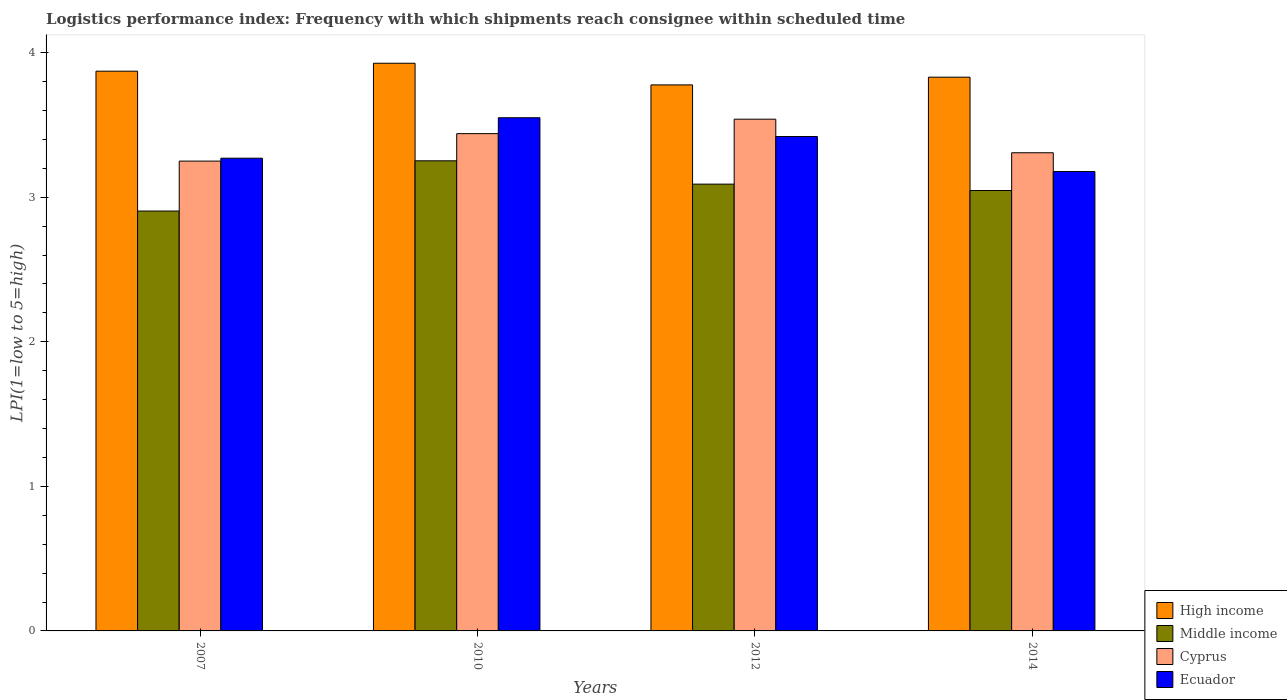Are the number of bars per tick equal to the number of legend labels?
Your response must be concise. Yes. How many bars are there on the 3rd tick from the left?
Your response must be concise. 4. What is the label of the 3rd group of bars from the left?
Provide a short and direct response. 2012. What is the logistics performance index in High income in 2007?
Provide a succinct answer. 3.87. Across all years, what is the maximum logistics performance index in Ecuador?
Keep it short and to the point. 3.55. Across all years, what is the minimum logistics performance index in Middle income?
Provide a succinct answer. 2.9. In which year was the logistics performance index in High income maximum?
Your answer should be very brief. 2010. In which year was the logistics performance index in Cyprus minimum?
Give a very brief answer. 2007. What is the total logistics performance index in High income in the graph?
Provide a succinct answer. 15.41. What is the difference between the logistics performance index in High income in 2007 and that in 2014?
Keep it short and to the point. 0.04. What is the difference between the logistics performance index in Cyprus in 2010 and the logistics performance index in Ecuador in 2014?
Your response must be concise. 0.26. What is the average logistics performance index in High income per year?
Make the answer very short. 3.85. In the year 2012, what is the difference between the logistics performance index in High income and logistics performance index in Middle income?
Keep it short and to the point. 0.69. In how many years, is the logistics performance index in Cyprus greater than 0.4?
Keep it short and to the point. 4. What is the ratio of the logistics performance index in Cyprus in 2007 to that in 2014?
Your answer should be very brief. 0.98. Is the difference between the logistics performance index in High income in 2007 and 2010 greater than the difference between the logistics performance index in Middle income in 2007 and 2010?
Provide a short and direct response. Yes. What is the difference between the highest and the second highest logistics performance index in High income?
Provide a short and direct response. 0.05. What is the difference between the highest and the lowest logistics performance index in Cyprus?
Your answer should be compact. 0.29. In how many years, is the logistics performance index in Middle income greater than the average logistics performance index in Middle income taken over all years?
Provide a short and direct response. 2. Is the sum of the logistics performance index in Ecuador in 2007 and 2014 greater than the maximum logistics performance index in High income across all years?
Give a very brief answer. Yes. What is the difference between two consecutive major ticks on the Y-axis?
Your answer should be compact. 1. Are the values on the major ticks of Y-axis written in scientific E-notation?
Give a very brief answer. No. Does the graph contain any zero values?
Make the answer very short. No. Where does the legend appear in the graph?
Give a very brief answer. Bottom right. What is the title of the graph?
Offer a very short reply. Logistics performance index: Frequency with which shipments reach consignee within scheduled time. Does "Liberia" appear as one of the legend labels in the graph?
Offer a terse response. No. What is the label or title of the X-axis?
Offer a very short reply. Years. What is the label or title of the Y-axis?
Make the answer very short. LPI(1=low to 5=high). What is the LPI(1=low to 5=high) in High income in 2007?
Make the answer very short. 3.87. What is the LPI(1=low to 5=high) of Middle income in 2007?
Your answer should be very brief. 2.9. What is the LPI(1=low to 5=high) in Ecuador in 2007?
Provide a succinct answer. 3.27. What is the LPI(1=low to 5=high) of High income in 2010?
Provide a succinct answer. 3.93. What is the LPI(1=low to 5=high) in Middle income in 2010?
Make the answer very short. 3.25. What is the LPI(1=low to 5=high) in Cyprus in 2010?
Provide a short and direct response. 3.44. What is the LPI(1=low to 5=high) of Ecuador in 2010?
Make the answer very short. 3.55. What is the LPI(1=low to 5=high) in High income in 2012?
Give a very brief answer. 3.78. What is the LPI(1=low to 5=high) in Middle income in 2012?
Your response must be concise. 3.09. What is the LPI(1=low to 5=high) of Cyprus in 2012?
Your answer should be very brief. 3.54. What is the LPI(1=low to 5=high) in Ecuador in 2012?
Your answer should be compact. 3.42. What is the LPI(1=low to 5=high) of High income in 2014?
Provide a short and direct response. 3.83. What is the LPI(1=low to 5=high) in Middle income in 2014?
Give a very brief answer. 3.05. What is the LPI(1=low to 5=high) of Cyprus in 2014?
Offer a very short reply. 3.31. What is the LPI(1=low to 5=high) of Ecuador in 2014?
Your response must be concise. 3.18. Across all years, what is the maximum LPI(1=low to 5=high) in High income?
Provide a short and direct response. 3.93. Across all years, what is the maximum LPI(1=low to 5=high) in Middle income?
Make the answer very short. 3.25. Across all years, what is the maximum LPI(1=low to 5=high) of Cyprus?
Keep it short and to the point. 3.54. Across all years, what is the maximum LPI(1=low to 5=high) of Ecuador?
Give a very brief answer. 3.55. Across all years, what is the minimum LPI(1=low to 5=high) in High income?
Ensure brevity in your answer.  3.78. Across all years, what is the minimum LPI(1=low to 5=high) in Middle income?
Ensure brevity in your answer.  2.9. Across all years, what is the minimum LPI(1=low to 5=high) in Ecuador?
Keep it short and to the point. 3.18. What is the total LPI(1=low to 5=high) in High income in the graph?
Provide a succinct answer. 15.41. What is the total LPI(1=low to 5=high) of Middle income in the graph?
Your response must be concise. 12.29. What is the total LPI(1=low to 5=high) in Cyprus in the graph?
Ensure brevity in your answer.  13.54. What is the total LPI(1=low to 5=high) of Ecuador in the graph?
Give a very brief answer. 13.42. What is the difference between the LPI(1=low to 5=high) in High income in 2007 and that in 2010?
Provide a succinct answer. -0.05. What is the difference between the LPI(1=low to 5=high) of Middle income in 2007 and that in 2010?
Offer a very short reply. -0.35. What is the difference between the LPI(1=low to 5=high) of Cyprus in 2007 and that in 2010?
Provide a short and direct response. -0.19. What is the difference between the LPI(1=low to 5=high) in Ecuador in 2007 and that in 2010?
Make the answer very short. -0.28. What is the difference between the LPI(1=low to 5=high) of High income in 2007 and that in 2012?
Make the answer very short. 0.09. What is the difference between the LPI(1=low to 5=high) of Middle income in 2007 and that in 2012?
Ensure brevity in your answer.  -0.19. What is the difference between the LPI(1=low to 5=high) of Cyprus in 2007 and that in 2012?
Give a very brief answer. -0.29. What is the difference between the LPI(1=low to 5=high) in Ecuador in 2007 and that in 2012?
Provide a succinct answer. -0.15. What is the difference between the LPI(1=low to 5=high) in High income in 2007 and that in 2014?
Offer a very short reply. 0.04. What is the difference between the LPI(1=low to 5=high) in Middle income in 2007 and that in 2014?
Ensure brevity in your answer.  -0.14. What is the difference between the LPI(1=low to 5=high) of Cyprus in 2007 and that in 2014?
Offer a very short reply. -0.06. What is the difference between the LPI(1=low to 5=high) in Ecuador in 2007 and that in 2014?
Make the answer very short. 0.09. What is the difference between the LPI(1=low to 5=high) in High income in 2010 and that in 2012?
Offer a terse response. 0.15. What is the difference between the LPI(1=low to 5=high) of Middle income in 2010 and that in 2012?
Your answer should be compact. 0.16. What is the difference between the LPI(1=low to 5=high) of Cyprus in 2010 and that in 2012?
Provide a succinct answer. -0.1. What is the difference between the LPI(1=low to 5=high) in Ecuador in 2010 and that in 2012?
Give a very brief answer. 0.13. What is the difference between the LPI(1=low to 5=high) in High income in 2010 and that in 2014?
Your answer should be very brief. 0.1. What is the difference between the LPI(1=low to 5=high) of Middle income in 2010 and that in 2014?
Give a very brief answer. 0.21. What is the difference between the LPI(1=low to 5=high) in Cyprus in 2010 and that in 2014?
Offer a very short reply. 0.13. What is the difference between the LPI(1=low to 5=high) in Ecuador in 2010 and that in 2014?
Keep it short and to the point. 0.37. What is the difference between the LPI(1=low to 5=high) in High income in 2012 and that in 2014?
Keep it short and to the point. -0.05. What is the difference between the LPI(1=low to 5=high) in Middle income in 2012 and that in 2014?
Your response must be concise. 0.04. What is the difference between the LPI(1=low to 5=high) in Cyprus in 2012 and that in 2014?
Offer a very short reply. 0.23. What is the difference between the LPI(1=low to 5=high) of Ecuador in 2012 and that in 2014?
Your response must be concise. 0.24. What is the difference between the LPI(1=low to 5=high) of High income in 2007 and the LPI(1=low to 5=high) of Middle income in 2010?
Your response must be concise. 0.62. What is the difference between the LPI(1=low to 5=high) of High income in 2007 and the LPI(1=low to 5=high) of Cyprus in 2010?
Your answer should be compact. 0.43. What is the difference between the LPI(1=low to 5=high) in High income in 2007 and the LPI(1=low to 5=high) in Ecuador in 2010?
Your answer should be very brief. 0.32. What is the difference between the LPI(1=low to 5=high) in Middle income in 2007 and the LPI(1=low to 5=high) in Cyprus in 2010?
Your response must be concise. -0.54. What is the difference between the LPI(1=low to 5=high) in Middle income in 2007 and the LPI(1=low to 5=high) in Ecuador in 2010?
Your answer should be compact. -0.65. What is the difference between the LPI(1=low to 5=high) of Cyprus in 2007 and the LPI(1=low to 5=high) of Ecuador in 2010?
Keep it short and to the point. -0.3. What is the difference between the LPI(1=low to 5=high) of High income in 2007 and the LPI(1=low to 5=high) of Middle income in 2012?
Your response must be concise. 0.78. What is the difference between the LPI(1=low to 5=high) in High income in 2007 and the LPI(1=low to 5=high) in Cyprus in 2012?
Your response must be concise. 0.33. What is the difference between the LPI(1=low to 5=high) in High income in 2007 and the LPI(1=low to 5=high) in Ecuador in 2012?
Give a very brief answer. 0.45. What is the difference between the LPI(1=low to 5=high) of Middle income in 2007 and the LPI(1=low to 5=high) of Cyprus in 2012?
Offer a terse response. -0.64. What is the difference between the LPI(1=low to 5=high) in Middle income in 2007 and the LPI(1=low to 5=high) in Ecuador in 2012?
Your answer should be very brief. -0.52. What is the difference between the LPI(1=low to 5=high) in Cyprus in 2007 and the LPI(1=low to 5=high) in Ecuador in 2012?
Ensure brevity in your answer.  -0.17. What is the difference between the LPI(1=low to 5=high) in High income in 2007 and the LPI(1=low to 5=high) in Middle income in 2014?
Ensure brevity in your answer.  0.83. What is the difference between the LPI(1=low to 5=high) in High income in 2007 and the LPI(1=low to 5=high) in Cyprus in 2014?
Give a very brief answer. 0.56. What is the difference between the LPI(1=low to 5=high) in High income in 2007 and the LPI(1=low to 5=high) in Ecuador in 2014?
Your answer should be compact. 0.69. What is the difference between the LPI(1=low to 5=high) in Middle income in 2007 and the LPI(1=low to 5=high) in Cyprus in 2014?
Provide a succinct answer. -0.4. What is the difference between the LPI(1=low to 5=high) of Middle income in 2007 and the LPI(1=low to 5=high) of Ecuador in 2014?
Your answer should be very brief. -0.27. What is the difference between the LPI(1=low to 5=high) of Cyprus in 2007 and the LPI(1=low to 5=high) of Ecuador in 2014?
Keep it short and to the point. 0.07. What is the difference between the LPI(1=low to 5=high) of High income in 2010 and the LPI(1=low to 5=high) of Middle income in 2012?
Ensure brevity in your answer.  0.84. What is the difference between the LPI(1=low to 5=high) in High income in 2010 and the LPI(1=low to 5=high) in Cyprus in 2012?
Give a very brief answer. 0.39. What is the difference between the LPI(1=low to 5=high) of High income in 2010 and the LPI(1=low to 5=high) of Ecuador in 2012?
Your response must be concise. 0.51. What is the difference between the LPI(1=low to 5=high) in Middle income in 2010 and the LPI(1=low to 5=high) in Cyprus in 2012?
Make the answer very short. -0.29. What is the difference between the LPI(1=low to 5=high) in Middle income in 2010 and the LPI(1=low to 5=high) in Ecuador in 2012?
Give a very brief answer. -0.17. What is the difference between the LPI(1=low to 5=high) of Cyprus in 2010 and the LPI(1=low to 5=high) of Ecuador in 2012?
Give a very brief answer. 0.02. What is the difference between the LPI(1=low to 5=high) in High income in 2010 and the LPI(1=low to 5=high) in Middle income in 2014?
Offer a terse response. 0.88. What is the difference between the LPI(1=low to 5=high) of High income in 2010 and the LPI(1=low to 5=high) of Cyprus in 2014?
Your answer should be compact. 0.62. What is the difference between the LPI(1=low to 5=high) in High income in 2010 and the LPI(1=low to 5=high) in Ecuador in 2014?
Provide a succinct answer. 0.75. What is the difference between the LPI(1=low to 5=high) in Middle income in 2010 and the LPI(1=low to 5=high) in Cyprus in 2014?
Make the answer very short. -0.06. What is the difference between the LPI(1=low to 5=high) of Middle income in 2010 and the LPI(1=low to 5=high) of Ecuador in 2014?
Ensure brevity in your answer.  0.07. What is the difference between the LPI(1=low to 5=high) in Cyprus in 2010 and the LPI(1=low to 5=high) in Ecuador in 2014?
Provide a short and direct response. 0.26. What is the difference between the LPI(1=low to 5=high) of High income in 2012 and the LPI(1=low to 5=high) of Middle income in 2014?
Keep it short and to the point. 0.73. What is the difference between the LPI(1=low to 5=high) in High income in 2012 and the LPI(1=low to 5=high) in Cyprus in 2014?
Keep it short and to the point. 0.47. What is the difference between the LPI(1=low to 5=high) in High income in 2012 and the LPI(1=low to 5=high) in Ecuador in 2014?
Provide a succinct answer. 0.6. What is the difference between the LPI(1=low to 5=high) of Middle income in 2012 and the LPI(1=low to 5=high) of Cyprus in 2014?
Make the answer very short. -0.22. What is the difference between the LPI(1=low to 5=high) in Middle income in 2012 and the LPI(1=low to 5=high) in Ecuador in 2014?
Your answer should be very brief. -0.09. What is the difference between the LPI(1=low to 5=high) of Cyprus in 2012 and the LPI(1=low to 5=high) of Ecuador in 2014?
Make the answer very short. 0.36. What is the average LPI(1=low to 5=high) in High income per year?
Your response must be concise. 3.85. What is the average LPI(1=low to 5=high) of Middle income per year?
Your answer should be very brief. 3.07. What is the average LPI(1=low to 5=high) in Cyprus per year?
Ensure brevity in your answer.  3.38. What is the average LPI(1=low to 5=high) of Ecuador per year?
Keep it short and to the point. 3.35. In the year 2007, what is the difference between the LPI(1=low to 5=high) of High income and LPI(1=low to 5=high) of Middle income?
Give a very brief answer. 0.97. In the year 2007, what is the difference between the LPI(1=low to 5=high) in High income and LPI(1=low to 5=high) in Cyprus?
Your answer should be compact. 0.62. In the year 2007, what is the difference between the LPI(1=low to 5=high) in High income and LPI(1=low to 5=high) in Ecuador?
Make the answer very short. 0.6. In the year 2007, what is the difference between the LPI(1=low to 5=high) in Middle income and LPI(1=low to 5=high) in Cyprus?
Your response must be concise. -0.35. In the year 2007, what is the difference between the LPI(1=low to 5=high) in Middle income and LPI(1=low to 5=high) in Ecuador?
Keep it short and to the point. -0.37. In the year 2007, what is the difference between the LPI(1=low to 5=high) of Cyprus and LPI(1=low to 5=high) of Ecuador?
Offer a very short reply. -0.02. In the year 2010, what is the difference between the LPI(1=low to 5=high) in High income and LPI(1=low to 5=high) in Middle income?
Ensure brevity in your answer.  0.67. In the year 2010, what is the difference between the LPI(1=low to 5=high) in High income and LPI(1=low to 5=high) in Cyprus?
Keep it short and to the point. 0.49. In the year 2010, what is the difference between the LPI(1=low to 5=high) of High income and LPI(1=low to 5=high) of Ecuador?
Ensure brevity in your answer.  0.38. In the year 2010, what is the difference between the LPI(1=low to 5=high) of Middle income and LPI(1=low to 5=high) of Cyprus?
Your answer should be very brief. -0.19. In the year 2010, what is the difference between the LPI(1=low to 5=high) in Middle income and LPI(1=low to 5=high) in Ecuador?
Keep it short and to the point. -0.3. In the year 2010, what is the difference between the LPI(1=low to 5=high) of Cyprus and LPI(1=low to 5=high) of Ecuador?
Provide a short and direct response. -0.11. In the year 2012, what is the difference between the LPI(1=low to 5=high) of High income and LPI(1=low to 5=high) of Middle income?
Your answer should be very brief. 0.69. In the year 2012, what is the difference between the LPI(1=low to 5=high) in High income and LPI(1=low to 5=high) in Cyprus?
Your answer should be very brief. 0.24. In the year 2012, what is the difference between the LPI(1=low to 5=high) in High income and LPI(1=low to 5=high) in Ecuador?
Keep it short and to the point. 0.36. In the year 2012, what is the difference between the LPI(1=low to 5=high) of Middle income and LPI(1=low to 5=high) of Cyprus?
Provide a succinct answer. -0.45. In the year 2012, what is the difference between the LPI(1=low to 5=high) of Middle income and LPI(1=low to 5=high) of Ecuador?
Ensure brevity in your answer.  -0.33. In the year 2012, what is the difference between the LPI(1=low to 5=high) of Cyprus and LPI(1=low to 5=high) of Ecuador?
Your response must be concise. 0.12. In the year 2014, what is the difference between the LPI(1=low to 5=high) of High income and LPI(1=low to 5=high) of Middle income?
Keep it short and to the point. 0.78. In the year 2014, what is the difference between the LPI(1=low to 5=high) in High income and LPI(1=low to 5=high) in Cyprus?
Offer a terse response. 0.52. In the year 2014, what is the difference between the LPI(1=low to 5=high) in High income and LPI(1=low to 5=high) in Ecuador?
Ensure brevity in your answer.  0.65. In the year 2014, what is the difference between the LPI(1=low to 5=high) in Middle income and LPI(1=low to 5=high) in Cyprus?
Ensure brevity in your answer.  -0.26. In the year 2014, what is the difference between the LPI(1=low to 5=high) in Middle income and LPI(1=low to 5=high) in Ecuador?
Provide a succinct answer. -0.13. In the year 2014, what is the difference between the LPI(1=low to 5=high) of Cyprus and LPI(1=low to 5=high) of Ecuador?
Ensure brevity in your answer.  0.13. What is the ratio of the LPI(1=low to 5=high) of High income in 2007 to that in 2010?
Provide a short and direct response. 0.99. What is the ratio of the LPI(1=low to 5=high) in Middle income in 2007 to that in 2010?
Keep it short and to the point. 0.89. What is the ratio of the LPI(1=low to 5=high) of Cyprus in 2007 to that in 2010?
Keep it short and to the point. 0.94. What is the ratio of the LPI(1=low to 5=high) in Ecuador in 2007 to that in 2010?
Offer a very short reply. 0.92. What is the ratio of the LPI(1=low to 5=high) in High income in 2007 to that in 2012?
Your answer should be compact. 1.03. What is the ratio of the LPI(1=low to 5=high) of Middle income in 2007 to that in 2012?
Ensure brevity in your answer.  0.94. What is the ratio of the LPI(1=low to 5=high) in Cyprus in 2007 to that in 2012?
Keep it short and to the point. 0.92. What is the ratio of the LPI(1=low to 5=high) in Ecuador in 2007 to that in 2012?
Keep it short and to the point. 0.96. What is the ratio of the LPI(1=low to 5=high) of High income in 2007 to that in 2014?
Offer a terse response. 1.01. What is the ratio of the LPI(1=low to 5=high) of Middle income in 2007 to that in 2014?
Offer a very short reply. 0.95. What is the ratio of the LPI(1=low to 5=high) in Cyprus in 2007 to that in 2014?
Your answer should be compact. 0.98. What is the ratio of the LPI(1=low to 5=high) in Ecuador in 2007 to that in 2014?
Offer a very short reply. 1.03. What is the ratio of the LPI(1=low to 5=high) in High income in 2010 to that in 2012?
Offer a very short reply. 1.04. What is the ratio of the LPI(1=low to 5=high) of Middle income in 2010 to that in 2012?
Provide a succinct answer. 1.05. What is the ratio of the LPI(1=low to 5=high) in Cyprus in 2010 to that in 2012?
Offer a very short reply. 0.97. What is the ratio of the LPI(1=low to 5=high) in Ecuador in 2010 to that in 2012?
Ensure brevity in your answer.  1.04. What is the ratio of the LPI(1=low to 5=high) of High income in 2010 to that in 2014?
Your response must be concise. 1.03. What is the ratio of the LPI(1=low to 5=high) of Middle income in 2010 to that in 2014?
Provide a succinct answer. 1.07. What is the ratio of the LPI(1=low to 5=high) of Cyprus in 2010 to that in 2014?
Your response must be concise. 1.04. What is the ratio of the LPI(1=low to 5=high) of Ecuador in 2010 to that in 2014?
Your response must be concise. 1.12. What is the ratio of the LPI(1=low to 5=high) of High income in 2012 to that in 2014?
Make the answer very short. 0.99. What is the ratio of the LPI(1=low to 5=high) in Middle income in 2012 to that in 2014?
Offer a terse response. 1.01. What is the ratio of the LPI(1=low to 5=high) in Cyprus in 2012 to that in 2014?
Keep it short and to the point. 1.07. What is the ratio of the LPI(1=low to 5=high) in Ecuador in 2012 to that in 2014?
Provide a short and direct response. 1.08. What is the difference between the highest and the second highest LPI(1=low to 5=high) in High income?
Your answer should be compact. 0.05. What is the difference between the highest and the second highest LPI(1=low to 5=high) in Middle income?
Your answer should be very brief. 0.16. What is the difference between the highest and the second highest LPI(1=low to 5=high) of Cyprus?
Your answer should be compact. 0.1. What is the difference between the highest and the second highest LPI(1=low to 5=high) in Ecuador?
Keep it short and to the point. 0.13. What is the difference between the highest and the lowest LPI(1=low to 5=high) of High income?
Your response must be concise. 0.15. What is the difference between the highest and the lowest LPI(1=low to 5=high) of Middle income?
Offer a very short reply. 0.35. What is the difference between the highest and the lowest LPI(1=low to 5=high) of Cyprus?
Your response must be concise. 0.29. What is the difference between the highest and the lowest LPI(1=low to 5=high) of Ecuador?
Ensure brevity in your answer.  0.37. 